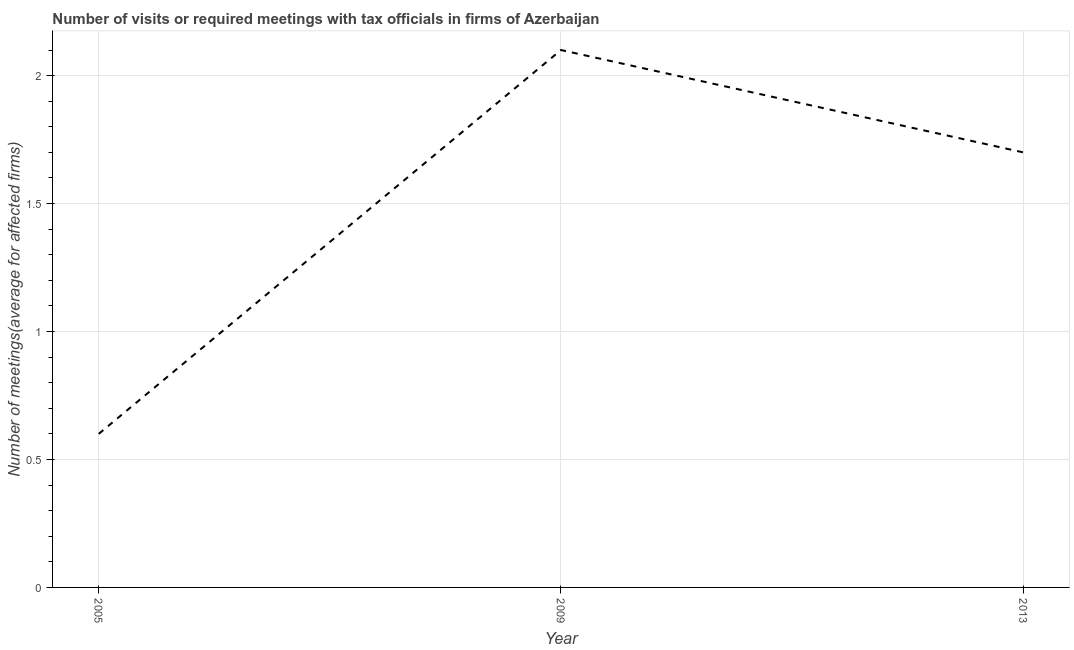Across all years, what is the maximum number of required meetings with tax officials?
Provide a short and direct response. 2.1. In which year was the number of required meetings with tax officials maximum?
Provide a short and direct response. 2009. What is the average number of required meetings with tax officials per year?
Ensure brevity in your answer.  1.47. What is the median number of required meetings with tax officials?
Offer a terse response. 1.7. In how many years, is the number of required meetings with tax officials greater than 0.2 ?
Offer a very short reply. 3. What is the ratio of the number of required meetings with tax officials in 2005 to that in 2009?
Your response must be concise. 0.29. Is the number of required meetings with tax officials in 2005 less than that in 2009?
Your response must be concise. Yes. What is the difference between the highest and the second highest number of required meetings with tax officials?
Provide a short and direct response. 0.4. What is the difference between the highest and the lowest number of required meetings with tax officials?
Ensure brevity in your answer.  1.5. In how many years, is the number of required meetings with tax officials greater than the average number of required meetings with tax officials taken over all years?
Offer a very short reply. 2. How many years are there in the graph?
Your answer should be compact. 3. Are the values on the major ticks of Y-axis written in scientific E-notation?
Your answer should be compact. No. What is the title of the graph?
Provide a short and direct response. Number of visits or required meetings with tax officials in firms of Azerbaijan. What is the label or title of the Y-axis?
Your answer should be compact. Number of meetings(average for affected firms). What is the Number of meetings(average for affected firms) of 2009?
Keep it short and to the point. 2.1. What is the difference between the Number of meetings(average for affected firms) in 2005 and 2009?
Offer a very short reply. -1.5. What is the difference between the Number of meetings(average for affected firms) in 2005 and 2013?
Provide a short and direct response. -1.1. What is the ratio of the Number of meetings(average for affected firms) in 2005 to that in 2009?
Offer a very short reply. 0.29. What is the ratio of the Number of meetings(average for affected firms) in 2005 to that in 2013?
Make the answer very short. 0.35. What is the ratio of the Number of meetings(average for affected firms) in 2009 to that in 2013?
Offer a very short reply. 1.24. 